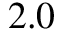<formula> <loc_0><loc_0><loc_500><loc_500>2 . 0</formula> 